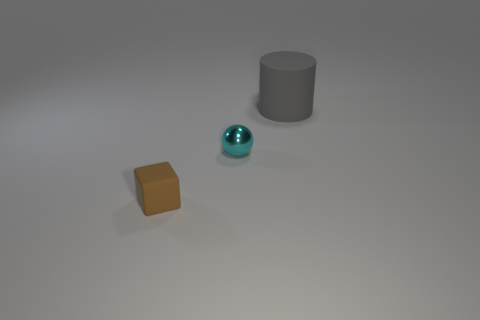What time of day does the lighting in this image suggest? The image has a neutral lighting with soft shadows, which suggests it might be an artificial setup with controlled lighting rather than natural light from a specific time of day. Could this be a setting for product photography? Yes, the neutral background and controlled lighting are typical for product photography, which requires clear, unobstructed views of the items without distracting elements. 